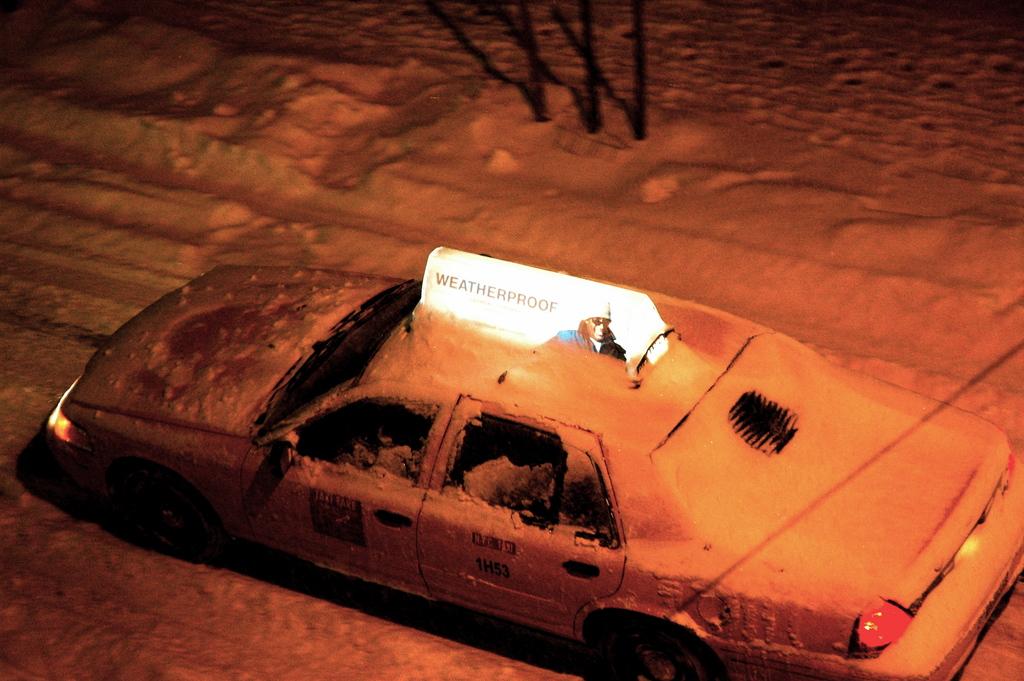What is proof?
Ensure brevity in your answer.  Weather. What does the lite up sign say?
Make the answer very short. Weatherproof. 